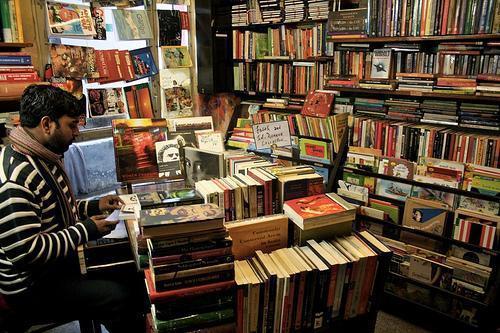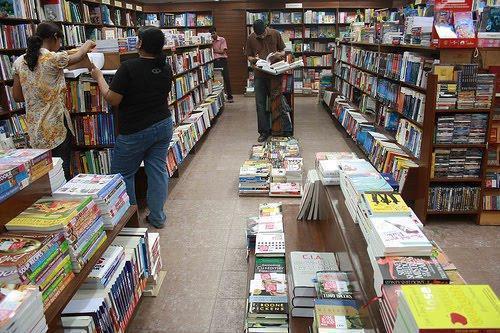The first image is the image on the left, the second image is the image on the right. Given the left and right images, does the statement "There are at least 4 people" hold true? Answer yes or no. Yes. 